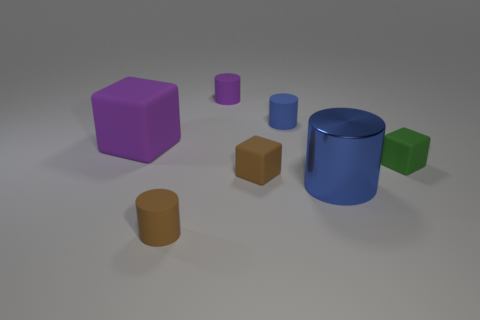Is there any other thing that has the same material as the big blue cylinder?
Keep it short and to the point. No. There is a big purple rubber thing; is it the same shape as the large object on the right side of the big block?
Your answer should be very brief. No. The other tiny object that is the same color as the metallic object is what shape?
Make the answer very short. Cylinder. What is the material of the tiny blue cylinder?
Your answer should be compact. Rubber. What shape is the brown object that is made of the same material as the brown cylinder?
Give a very brief answer. Cube. There is a brown cylinder on the left side of the large blue object that is left of the tiny green rubber cube; what is its size?
Your response must be concise. Small. What is the color of the cylinder in front of the big blue thing?
Give a very brief answer. Brown. Is there a tiny purple rubber object of the same shape as the large purple thing?
Offer a terse response. No. Is the number of small brown matte cylinders on the left side of the large purple matte object less than the number of large purple things that are left of the large shiny cylinder?
Offer a very short reply. Yes. What color is the big metal object?
Ensure brevity in your answer.  Blue. 